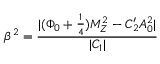Convert formula to latex. <formula><loc_0><loc_0><loc_500><loc_500>\beta ^ { 2 } = \frac { | ( \Phi _ { 0 } + \frac { 1 } { 4 } ) M _ { Z } ^ { 2 } - C _ { 2 } ^ { \prime } A _ { 0 } ^ { 2 } | } { | C _ { 1 } | }</formula> 